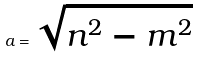Convert formula to latex. <formula><loc_0><loc_0><loc_500><loc_500>a = \sqrt { n ^ { 2 } - m ^ { 2 } }</formula> 